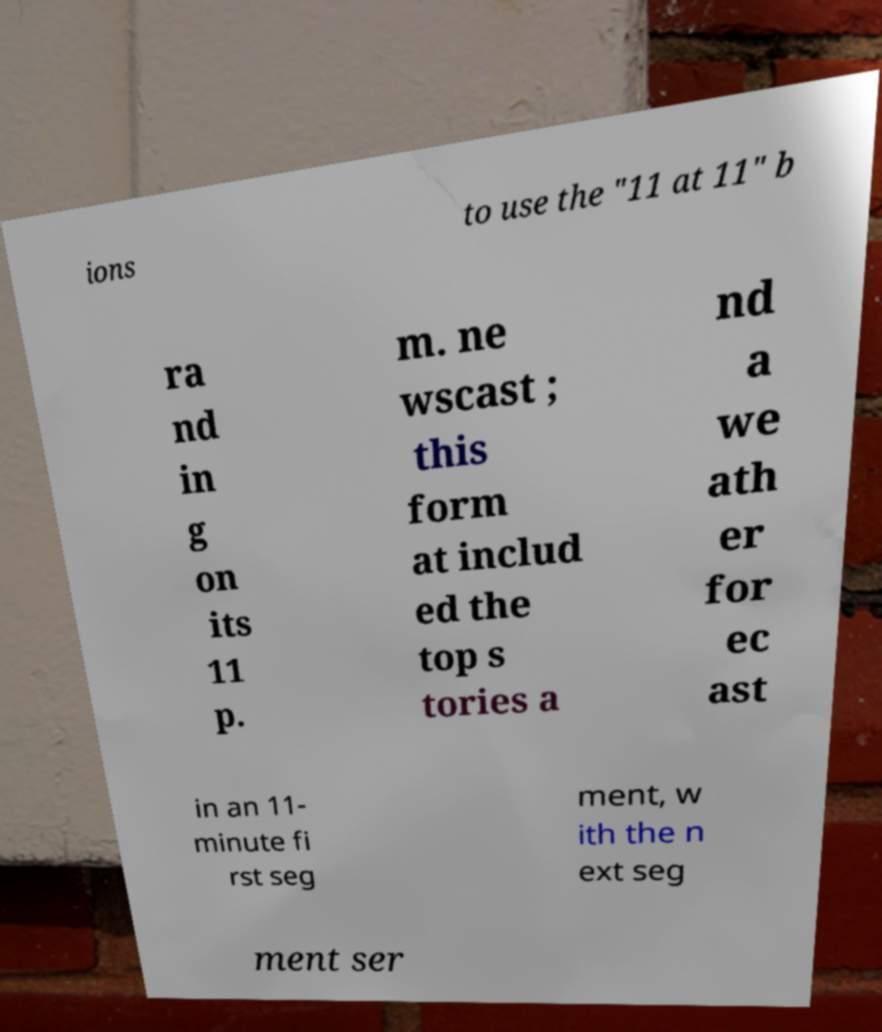I need the written content from this picture converted into text. Can you do that? ions to use the "11 at 11" b ra nd in g on its 11 p. m. ne wscast ; this form at includ ed the top s tories a nd a we ath er for ec ast in an 11- minute fi rst seg ment, w ith the n ext seg ment ser 